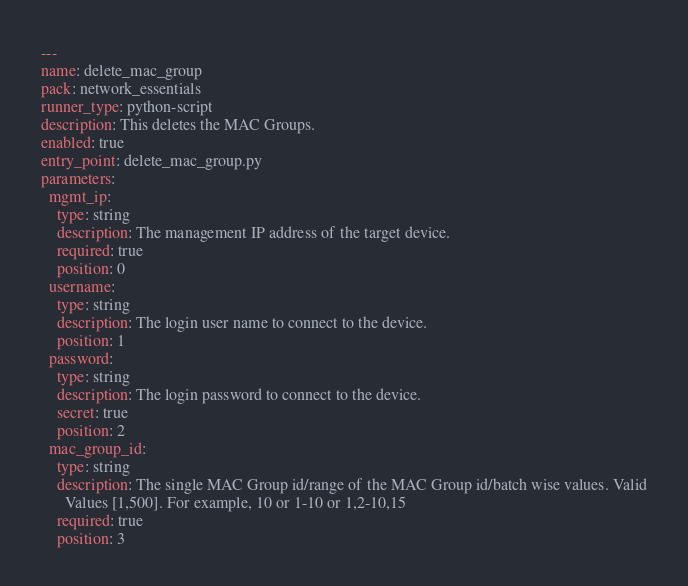<code> <loc_0><loc_0><loc_500><loc_500><_YAML_>---
name: delete_mac_group
pack: network_essentials
runner_type: python-script
description: This deletes the MAC Groups.
enabled: true
entry_point: delete_mac_group.py
parameters:
  mgmt_ip:
    type: string
    description: The management IP address of the target device.
    required: true
    position: 0
  username:
    type: string
    description: The login user name to connect to the device.
    position: 1
  password:
    type: string
    description: The login password to connect to the device.
    secret: true
    position: 2
  mac_group_id:
    type: string
    description: The single MAC Group id/range of the MAC Group id/batch wise values. Valid
      Values [1,500]. For example, 10 or 1-10 or 1,2-10,15
    required: true
    position: 3
</code> 